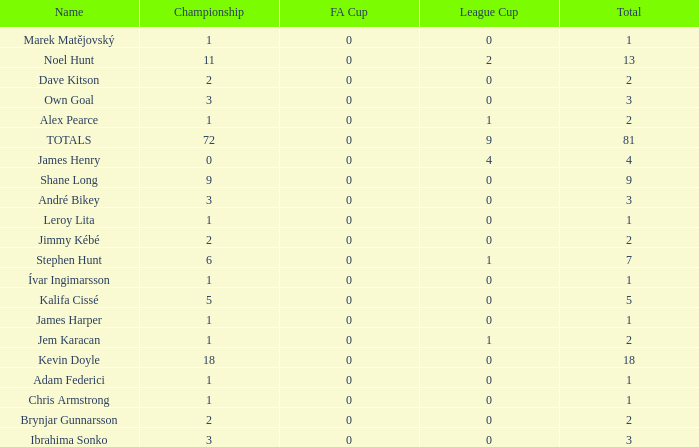What is the total championships that the league cup is less than 0? None. 